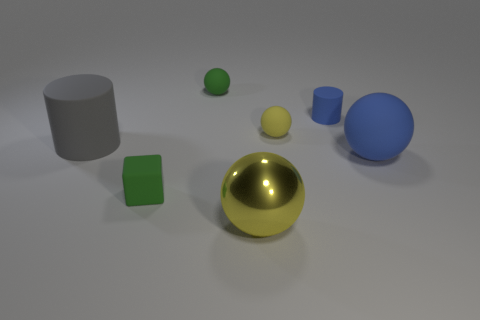Subtract all matte balls. How many balls are left? 1 Add 2 large gray rubber objects. How many objects exist? 9 Subtract all green spheres. How many spheres are left? 3 Subtract 0 red cylinders. How many objects are left? 7 Subtract all spheres. How many objects are left? 3 Subtract 1 cubes. How many cubes are left? 0 Subtract all red balls. Subtract all blue cubes. How many balls are left? 4 Subtract all blue balls. How many gray cubes are left? 0 Subtract all small blue things. Subtract all metal things. How many objects are left? 5 Add 4 tiny balls. How many tiny balls are left? 6 